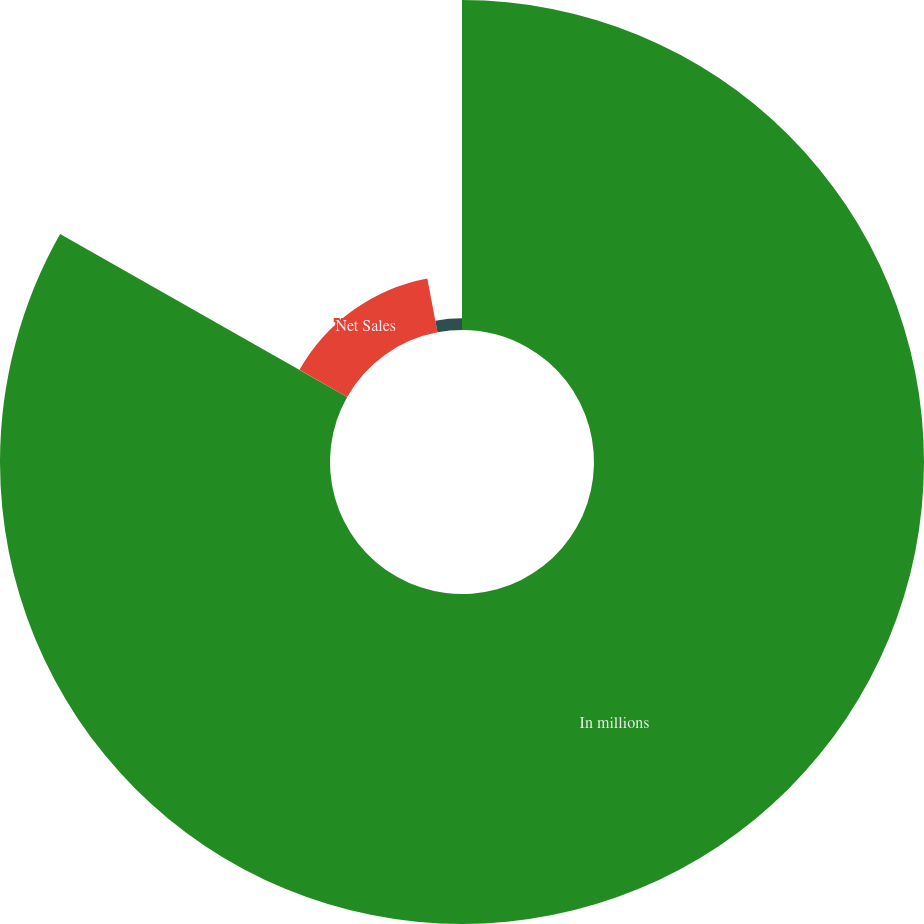<chart> <loc_0><loc_0><loc_500><loc_500><pie_chart><fcel>In millions<fcel>Net Sales<fcel>Operating Profit (Loss)<nl><fcel>83.21%<fcel>13.82%<fcel>2.97%<nl></chart> 